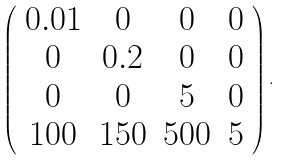Convert formula to latex. <formula><loc_0><loc_0><loc_500><loc_500>\left ( \begin{array} { c c c c } 0 . 0 1 & 0 & 0 & 0 \\ 0 & 0 . 2 & 0 & 0 \\ 0 & 0 & 5 & 0 \\ 1 0 0 & 1 5 0 & 5 0 0 & 5 \\ \end{array} \right ) .</formula> 